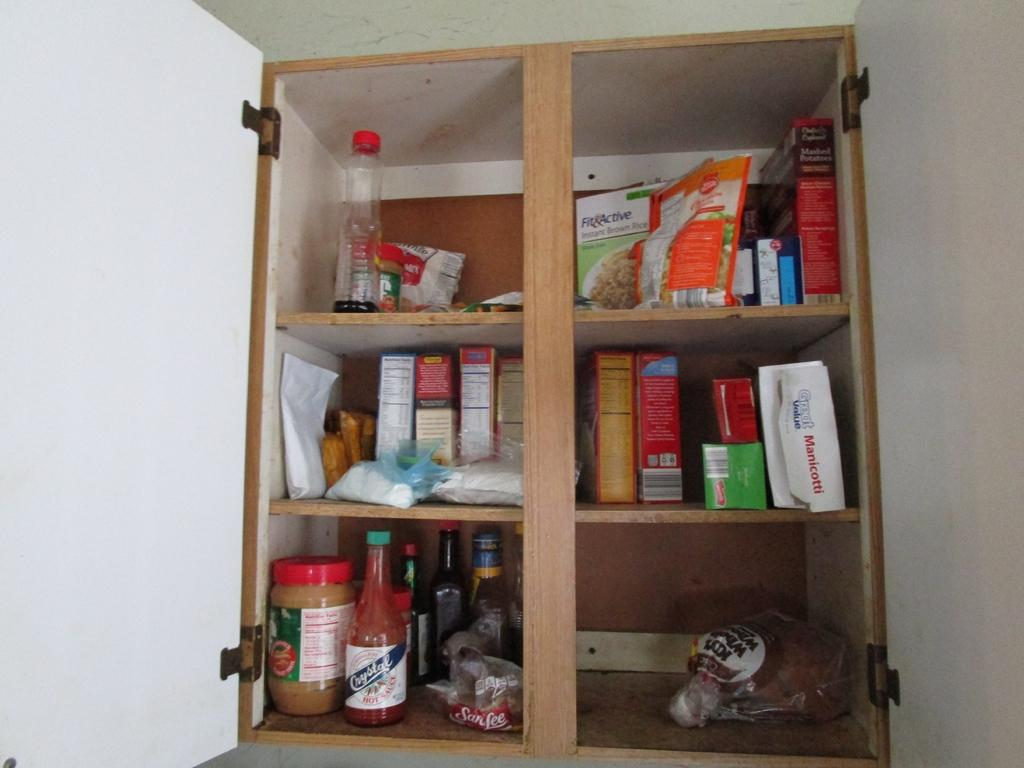<image>
Offer a succinct explanation of the picture presented. In a cluttered pantry a box of Fit Active rice is on the top shelf. 